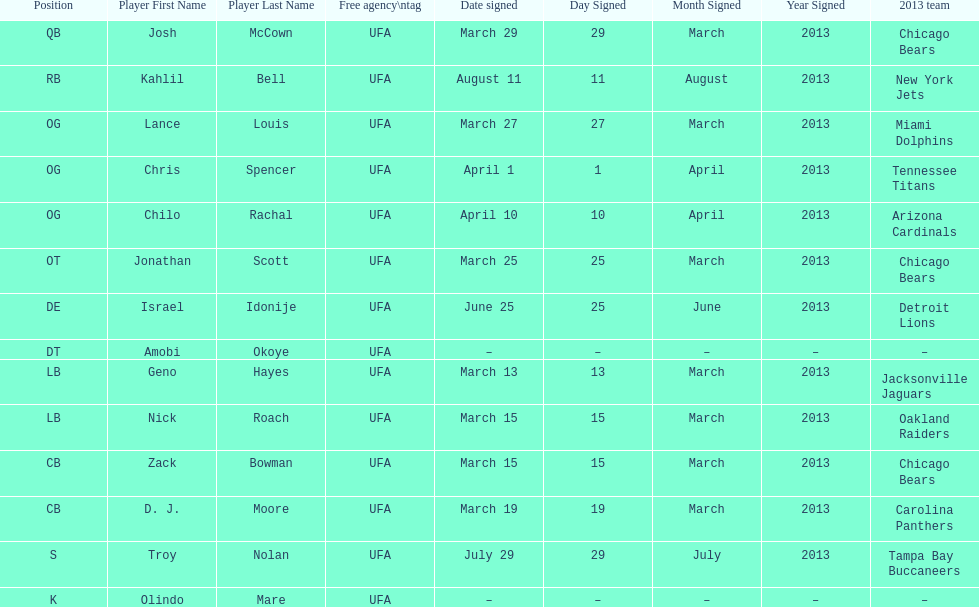How many players were signed in march? 7. 